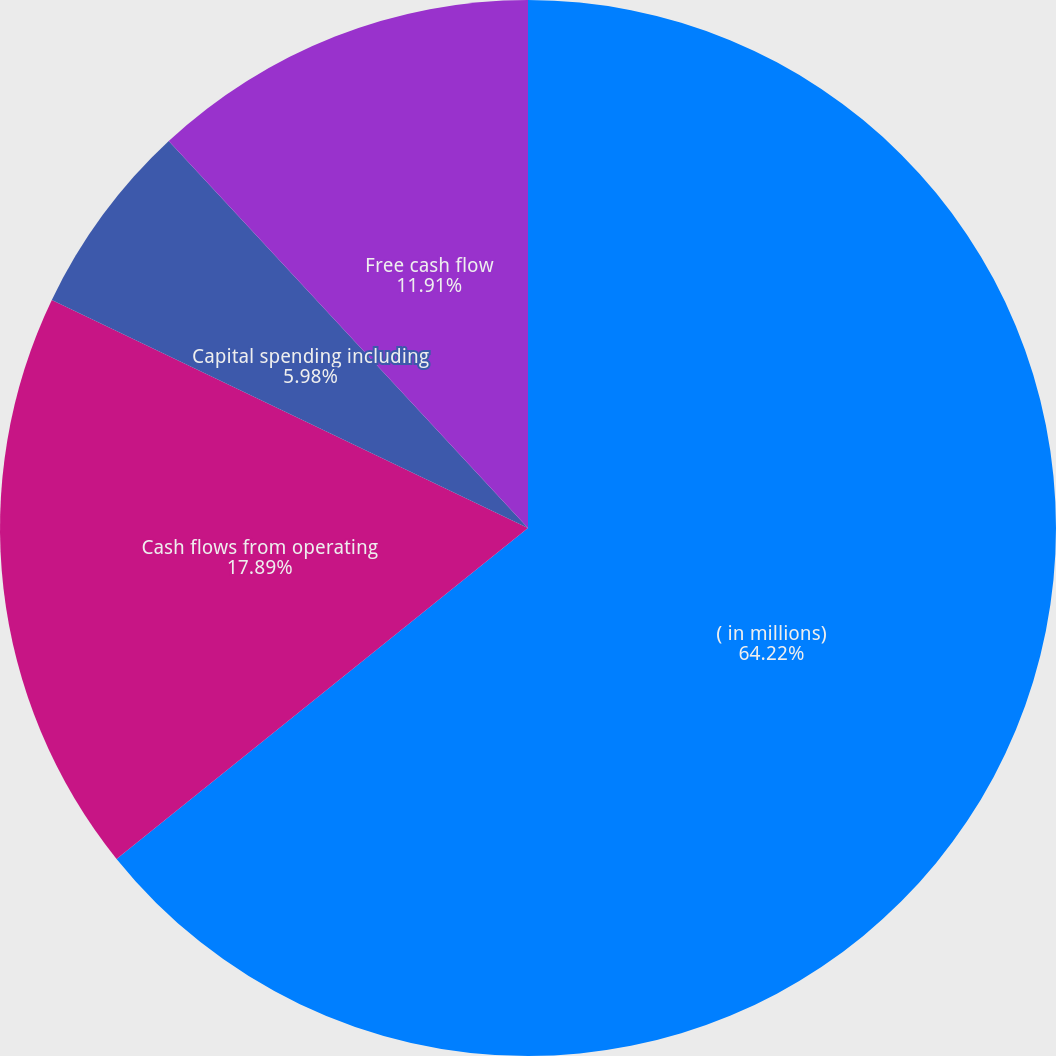Convert chart. <chart><loc_0><loc_0><loc_500><loc_500><pie_chart><fcel>( in millions)<fcel>Cash flows from operating<fcel>Capital spending including<fcel>Free cash flow<nl><fcel>64.22%<fcel>17.89%<fcel>5.98%<fcel>11.91%<nl></chart> 